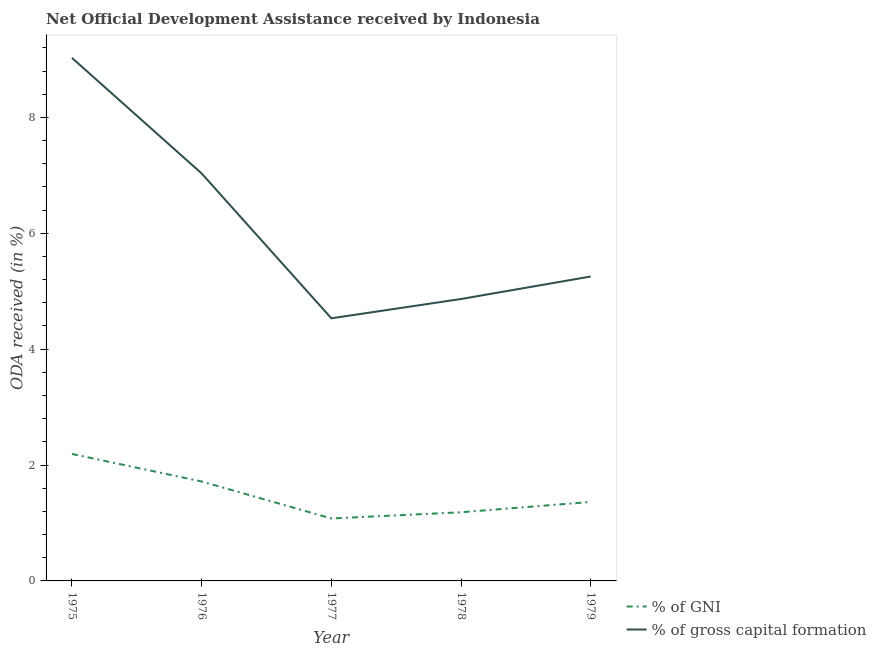How many different coloured lines are there?
Offer a very short reply. 2. Does the line corresponding to oda received as percentage of gni intersect with the line corresponding to oda received as percentage of gross capital formation?
Your response must be concise. No. What is the oda received as percentage of gross capital formation in 1979?
Make the answer very short. 5.25. Across all years, what is the maximum oda received as percentage of gni?
Your answer should be very brief. 2.19. Across all years, what is the minimum oda received as percentage of gni?
Keep it short and to the point. 1.08. In which year was the oda received as percentage of gross capital formation maximum?
Give a very brief answer. 1975. In which year was the oda received as percentage of gross capital formation minimum?
Provide a short and direct response. 1977. What is the total oda received as percentage of gross capital formation in the graph?
Your response must be concise. 30.71. What is the difference between the oda received as percentage of gni in 1975 and that in 1976?
Your answer should be very brief. 0.48. What is the difference between the oda received as percentage of gni in 1978 and the oda received as percentage of gross capital formation in 1976?
Offer a terse response. -5.85. What is the average oda received as percentage of gni per year?
Ensure brevity in your answer.  1.51. In the year 1978, what is the difference between the oda received as percentage of gni and oda received as percentage of gross capital formation?
Offer a very short reply. -3.68. What is the ratio of the oda received as percentage of gni in 1978 to that in 1979?
Give a very brief answer. 0.87. Is the oda received as percentage of gni in 1976 less than that in 1978?
Your answer should be very brief. No. What is the difference between the highest and the second highest oda received as percentage of gross capital formation?
Make the answer very short. 1.99. What is the difference between the highest and the lowest oda received as percentage of gross capital formation?
Your response must be concise. 4.49. In how many years, is the oda received as percentage of gni greater than the average oda received as percentage of gni taken over all years?
Make the answer very short. 2. Is the sum of the oda received as percentage of gross capital formation in 1978 and 1979 greater than the maximum oda received as percentage of gni across all years?
Provide a short and direct response. Yes. Is the oda received as percentage of gross capital formation strictly less than the oda received as percentage of gni over the years?
Provide a succinct answer. No. What is the difference between two consecutive major ticks on the Y-axis?
Ensure brevity in your answer.  2. Are the values on the major ticks of Y-axis written in scientific E-notation?
Your response must be concise. No. Does the graph contain any zero values?
Provide a short and direct response. No. Does the graph contain grids?
Make the answer very short. No. How many legend labels are there?
Give a very brief answer. 2. What is the title of the graph?
Offer a very short reply. Net Official Development Assistance received by Indonesia. Does "Under-five" appear as one of the legend labels in the graph?
Provide a short and direct response. No. What is the label or title of the Y-axis?
Ensure brevity in your answer.  ODA received (in %). What is the ODA received (in %) of % of GNI in 1975?
Provide a succinct answer. 2.19. What is the ODA received (in %) in % of gross capital formation in 1975?
Your response must be concise. 9.03. What is the ODA received (in %) of % of GNI in 1976?
Keep it short and to the point. 1.72. What is the ODA received (in %) in % of gross capital formation in 1976?
Offer a very short reply. 7.03. What is the ODA received (in %) of % of GNI in 1977?
Ensure brevity in your answer.  1.08. What is the ODA received (in %) in % of gross capital formation in 1977?
Your answer should be compact. 4.53. What is the ODA received (in %) in % of GNI in 1978?
Keep it short and to the point. 1.19. What is the ODA received (in %) in % of gross capital formation in 1978?
Offer a very short reply. 4.87. What is the ODA received (in %) of % of GNI in 1979?
Offer a very short reply. 1.36. What is the ODA received (in %) in % of gross capital formation in 1979?
Your answer should be compact. 5.25. Across all years, what is the maximum ODA received (in %) of % of GNI?
Give a very brief answer. 2.19. Across all years, what is the maximum ODA received (in %) of % of gross capital formation?
Provide a succinct answer. 9.03. Across all years, what is the minimum ODA received (in %) in % of GNI?
Ensure brevity in your answer.  1.08. Across all years, what is the minimum ODA received (in %) in % of gross capital formation?
Offer a very short reply. 4.53. What is the total ODA received (in %) in % of GNI in the graph?
Provide a short and direct response. 7.53. What is the total ODA received (in %) in % of gross capital formation in the graph?
Ensure brevity in your answer.  30.71. What is the difference between the ODA received (in %) in % of GNI in 1975 and that in 1976?
Provide a succinct answer. 0.48. What is the difference between the ODA received (in %) in % of gross capital formation in 1975 and that in 1976?
Keep it short and to the point. 1.99. What is the difference between the ODA received (in %) of % of GNI in 1975 and that in 1977?
Keep it short and to the point. 1.11. What is the difference between the ODA received (in %) in % of gross capital formation in 1975 and that in 1977?
Offer a very short reply. 4.49. What is the difference between the ODA received (in %) in % of GNI in 1975 and that in 1978?
Make the answer very short. 1.01. What is the difference between the ODA received (in %) in % of gross capital formation in 1975 and that in 1978?
Your answer should be compact. 4.16. What is the difference between the ODA received (in %) of % of GNI in 1975 and that in 1979?
Ensure brevity in your answer.  0.83. What is the difference between the ODA received (in %) in % of gross capital formation in 1975 and that in 1979?
Offer a terse response. 3.77. What is the difference between the ODA received (in %) in % of GNI in 1976 and that in 1977?
Make the answer very short. 0.64. What is the difference between the ODA received (in %) in % of gross capital formation in 1976 and that in 1977?
Give a very brief answer. 2.5. What is the difference between the ODA received (in %) in % of GNI in 1976 and that in 1978?
Provide a succinct answer. 0.53. What is the difference between the ODA received (in %) in % of gross capital formation in 1976 and that in 1978?
Your answer should be compact. 2.17. What is the difference between the ODA received (in %) of % of GNI in 1976 and that in 1979?
Provide a short and direct response. 0.35. What is the difference between the ODA received (in %) of % of gross capital formation in 1976 and that in 1979?
Ensure brevity in your answer.  1.78. What is the difference between the ODA received (in %) of % of GNI in 1977 and that in 1978?
Make the answer very short. -0.11. What is the difference between the ODA received (in %) of % of gross capital formation in 1977 and that in 1978?
Keep it short and to the point. -0.33. What is the difference between the ODA received (in %) of % of GNI in 1977 and that in 1979?
Make the answer very short. -0.29. What is the difference between the ODA received (in %) of % of gross capital formation in 1977 and that in 1979?
Give a very brief answer. -0.72. What is the difference between the ODA received (in %) of % of GNI in 1978 and that in 1979?
Give a very brief answer. -0.18. What is the difference between the ODA received (in %) in % of gross capital formation in 1978 and that in 1979?
Provide a short and direct response. -0.39. What is the difference between the ODA received (in %) in % of GNI in 1975 and the ODA received (in %) in % of gross capital formation in 1976?
Your answer should be compact. -4.84. What is the difference between the ODA received (in %) of % of GNI in 1975 and the ODA received (in %) of % of gross capital formation in 1977?
Provide a short and direct response. -2.34. What is the difference between the ODA received (in %) in % of GNI in 1975 and the ODA received (in %) in % of gross capital formation in 1978?
Your answer should be very brief. -2.67. What is the difference between the ODA received (in %) in % of GNI in 1975 and the ODA received (in %) in % of gross capital formation in 1979?
Your answer should be compact. -3.06. What is the difference between the ODA received (in %) in % of GNI in 1976 and the ODA received (in %) in % of gross capital formation in 1977?
Offer a very short reply. -2.82. What is the difference between the ODA received (in %) in % of GNI in 1976 and the ODA received (in %) in % of gross capital formation in 1978?
Ensure brevity in your answer.  -3.15. What is the difference between the ODA received (in %) in % of GNI in 1976 and the ODA received (in %) in % of gross capital formation in 1979?
Your answer should be very brief. -3.54. What is the difference between the ODA received (in %) in % of GNI in 1977 and the ODA received (in %) in % of gross capital formation in 1978?
Keep it short and to the point. -3.79. What is the difference between the ODA received (in %) in % of GNI in 1977 and the ODA received (in %) in % of gross capital formation in 1979?
Offer a terse response. -4.18. What is the difference between the ODA received (in %) in % of GNI in 1978 and the ODA received (in %) in % of gross capital formation in 1979?
Your answer should be compact. -4.07. What is the average ODA received (in %) of % of GNI per year?
Your answer should be compact. 1.51. What is the average ODA received (in %) of % of gross capital formation per year?
Make the answer very short. 6.14. In the year 1975, what is the difference between the ODA received (in %) of % of GNI and ODA received (in %) of % of gross capital formation?
Your answer should be compact. -6.83. In the year 1976, what is the difference between the ODA received (in %) in % of GNI and ODA received (in %) in % of gross capital formation?
Ensure brevity in your answer.  -5.32. In the year 1977, what is the difference between the ODA received (in %) in % of GNI and ODA received (in %) in % of gross capital formation?
Give a very brief answer. -3.45. In the year 1978, what is the difference between the ODA received (in %) of % of GNI and ODA received (in %) of % of gross capital formation?
Provide a succinct answer. -3.68. In the year 1979, what is the difference between the ODA received (in %) in % of GNI and ODA received (in %) in % of gross capital formation?
Ensure brevity in your answer.  -3.89. What is the ratio of the ODA received (in %) of % of GNI in 1975 to that in 1976?
Offer a very short reply. 1.28. What is the ratio of the ODA received (in %) of % of gross capital formation in 1975 to that in 1976?
Provide a short and direct response. 1.28. What is the ratio of the ODA received (in %) of % of GNI in 1975 to that in 1977?
Ensure brevity in your answer.  2.03. What is the ratio of the ODA received (in %) of % of gross capital formation in 1975 to that in 1977?
Provide a short and direct response. 1.99. What is the ratio of the ODA received (in %) of % of GNI in 1975 to that in 1978?
Your answer should be compact. 1.85. What is the ratio of the ODA received (in %) of % of gross capital formation in 1975 to that in 1978?
Make the answer very short. 1.86. What is the ratio of the ODA received (in %) of % of GNI in 1975 to that in 1979?
Your response must be concise. 1.61. What is the ratio of the ODA received (in %) in % of gross capital formation in 1975 to that in 1979?
Offer a terse response. 1.72. What is the ratio of the ODA received (in %) of % of GNI in 1976 to that in 1977?
Your answer should be very brief. 1.59. What is the ratio of the ODA received (in %) of % of gross capital formation in 1976 to that in 1977?
Your answer should be compact. 1.55. What is the ratio of the ODA received (in %) of % of GNI in 1976 to that in 1978?
Make the answer very short. 1.45. What is the ratio of the ODA received (in %) of % of gross capital formation in 1976 to that in 1978?
Ensure brevity in your answer.  1.45. What is the ratio of the ODA received (in %) in % of GNI in 1976 to that in 1979?
Make the answer very short. 1.26. What is the ratio of the ODA received (in %) of % of gross capital formation in 1976 to that in 1979?
Provide a short and direct response. 1.34. What is the ratio of the ODA received (in %) in % of GNI in 1977 to that in 1978?
Your answer should be very brief. 0.91. What is the ratio of the ODA received (in %) of % of gross capital formation in 1977 to that in 1978?
Your answer should be compact. 0.93. What is the ratio of the ODA received (in %) of % of GNI in 1977 to that in 1979?
Ensure brevity in your answer.  0.79. What is the ratio of the ODA received (in %) of % of gross capital formation in 1977 to that in 1979?
Offer a very short reply. 0.86. What is the ratio of the ODA received (in %) in % of GNI in 1978 to that in 1979?
Make the answer very short. 0.87. What is the ratio of the ODA received (in %) of % of gross capital formation in 1978 to that in 1979?
Your answer should be very brief. 0.93. What is the difference between the highest and the second highest ODA received (in %) in % of GNI?
Offer a very short reply. 0.48. What is the difference between the highest and the second highest ODA received (in %) of % of gross capital formation?
Provide a succinct answer. 1.99. What is the difference between the highest and the lowest ODA received (in %) in % of GNI?
Give a very brief answer. 1.11. What is the difference between the highest and the lowest ODA received (in %) in % of gross capital formation?
Ensure brevity in your answer.  4.49. 